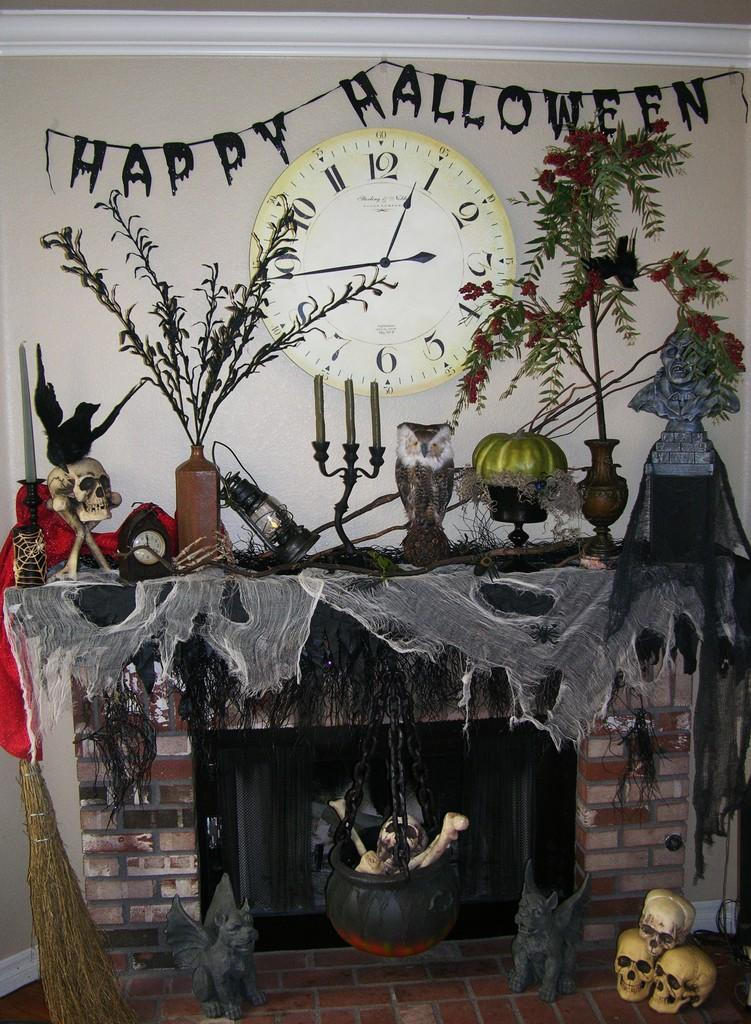<image>
Give a short and clear explanation of the subsequent image. A fireplace mantle with multiple Halloween decorations and a clock that reads 12:45 